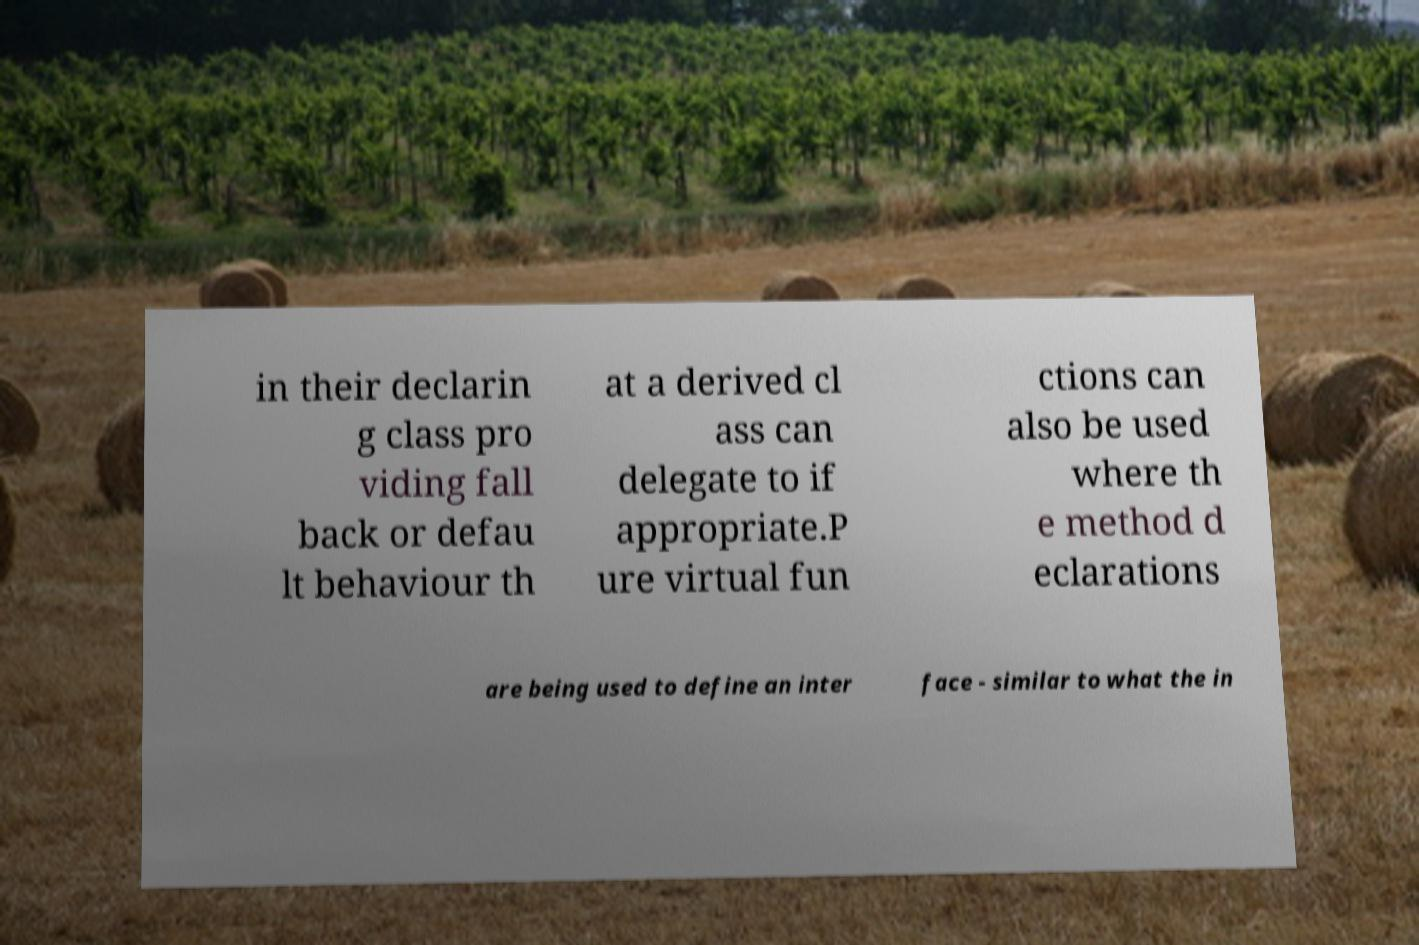For documentation purposes, I need the text within this image transcribed. Could you provide that? in their declarin g class pro viding fall back or defau lt behaviour th at a derived cl ass can delegate to if appropriate.P ure virtual fun ctions can also be used where th e method d eclarations are being used to define an inter face - similar to what the in 